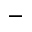Convert formula to latex. <formula><loc_0><loc_0><loc_500><loc_500>^ { - }</formula> 